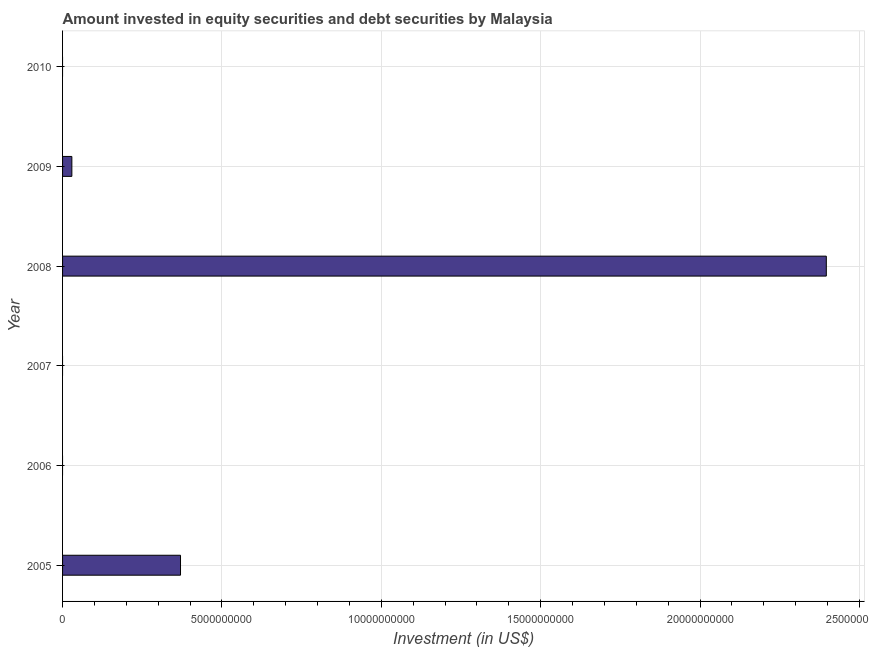Does the graph contain any zero values?
Give a very brief answer. Yes. What is the title of the graph?
Your answer should be very brief. Amount invested in equity securities and debt securities by Malaysia. What is the label or title of the X-axis?
Ensure brevity in your answer.  Investment (in US$). What is the label or title of the Y-axis?
Provide a succinct answer. Year. What is the portfolio investment in 2005?
Your answer should be very brief. 3.70e+09. Across all years, what is the maximum portfolio investment?
Provide a short and direct response. 2.40e+1. Across all years, what is the minimum portfolio investment?
Ensure brevity in your answer.  0. In which year was the portfolio investment maximum?
Keep it short and to the point. 2008. What is the sum of the portfolio investment?
Ensure brevity in your answer.  2.80e+1. What is the difference between the portfolio investment in 2005 and 2008?
Make the answer very short. -2.03e+1. What is the average portfolio investment per year?
Your answer should be compact. 4.66e+09. What is the median portfolio investment?
Give a very brief answer. 1.46e+08. What is the ratio of the portfolio investment in 2008 to that in 2009?
Provide a succinct answer. 82.23. Is the portfolio investment in 2005 less than that in 2009?
Give a very brief answer. No. What is the difference between the highest and the second highest portfolio investment?
Keep it short and to the point. 2.03e+1. What is the difference between the highest and the lowest portfolio investment?
Ensure brevity in your answer.  2.40e+1. In how many years, is the portfolio investment greater than the average portfolio investment taken over all years?
Ensure brevity in your answer.  1. How many years are there in the graph?
Keep it short and to the point. 6. What is the difference between two consecutive major ticks on the X-axis?
Give a very brief answer. 5.00e+09. What is the Investment (in US$) in 2005?
Provide a short and direct response. 3.70e+09. What is the Investment (in US$) of 2008?
Your response must be concise. 2.40e+1. What is the Investment (in US$) in 2009?
Ensure brevity in your answer.  2.91e+08. What is the Investment (in US$) in 2010?
Offer a very short reply. 0. What is the difference between the Investment (in US$) in 2005 and 2008?
Give a very brief answer. -2.03e+1. What is the difference between the Investment (in US$) in 2005 and 2009?
Keep it short and to the point. 3.41e+09. What is the difference between the Investment (in US$) in 2008 and 2009?
Provide a short and direct response. 2.37e+1. What is the ratio of the Investment (in US$) in 2005 to that in 2008?
Make the answer very short. 0.15. What is the ratio of the Investment (in US$) in 2005 to that in 2009?
Provide a short and direct response. 12.7. What is the ratio of the Investment (in US$) in 2008 to that in 2009?
Your response must be concise. 82.23. 